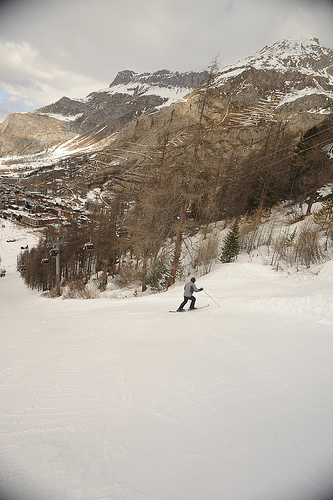Describe the surroundings visible around the ski area. Surrounding the ski area are rugged mountain peaks with patches of snow and exposed rock. The treeline is visible with coniferous trees, and there is a small cluster of buildings at the base, likely accommodation or amenities for skiers. Does the ski area look crowded? In the image, the ski area does not appear to be crowded. The slopes seem fairly open with only one skier visible, which might indicate a more relaxed skiing experience. 